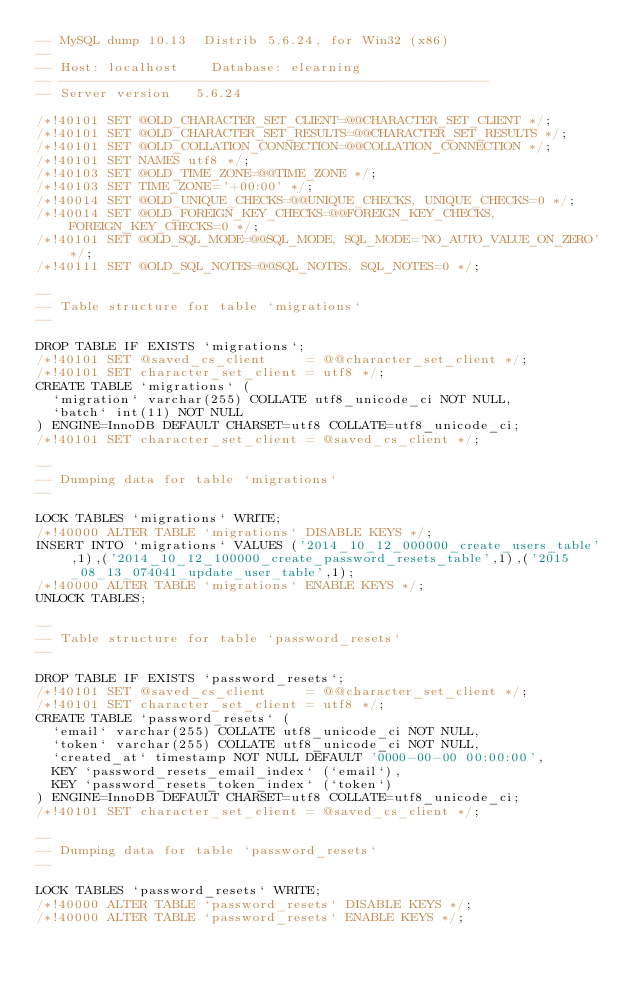Convert code to text. <code><loc_0><loc_0><loc_500><loc_500><_SQL_>-- MySQL dump 10.13  Distrib 5.6.24, for Win32 (x86)
--
-- Host: localhost    Database: elearning
-- ------------------------------------------------------
-- Server version	5.6.24

/*!40101 SET @OLD_CHARACTER_SET_CLIENT=@@CHARACTER_SET_CLIENT */;
/*!40101 SET @OLD_CHARACTER_SET_RESULTS=@@CHARACTER_SET_RESULTS */;
/*!40101 SET @OLD_COLLATION_CONNECTION=@@COLLATION_CONNECTION */;
/*!40101 SET NAMES utf8 */;
/*!40103 SET @OLD_TIME_ZONE=@@TIME_ZONE */;
/*!40103 SET TIME_ZONE='+00:00' */;
/*!40014 SET @OLD_UNIQUE_CHECKS=@@UNIQUE_CHECKS, UNIQUE_CHECKS=0 */;
/*!40014 SET @OLD_FOREIGN_KEY_CHECKS=@@FOREIGN_KEY_CHECKS, FOREIGN_KEY_CHECKS=0 */;
/*!40101 SET @OLD_SQL_MODE=@@SQL_MODE, SQL_MODE='NO_AUTO_VALUE_ON_ZERO' */;
/*!40111 SET @OLD_SQL_NOTES=@@SQL_NOTES, SQL_NOTES=0 */;

--
-- Table structure for table `migrations`
--

DROP TABLE IF EXISTS `migrations`;
/*!40101 SET @saved_cs_client     = @@character_set_client */;
/*!40101 SET character_set_client = utf8 */;
CREATE TABLE `migrations` (
  `migration` varchar(255) COLLATE utf8_unicode_ci NOT NULL,
  `batch` int(11) NOT NULL
) ENGINE=InnoDB DEFAULT CHARSET=utf8 COLLATE=utf8_unicode_ci;
/*!40101 SET character_set_client = @saved_cs_client */;

--
-- Dumping data for table `migrations`
--

LOCK TABLES `migrations` WRITE;
/*!40000 ALTER TABLE `migrations` DISABLE KEYS */;
INSERT INTO `migrations` VALUES ('2014_10_12_000000_create_users_table',1),('2014_10_12_100000_create_password_resets_table',1),('2015_08_13_074041_update_user_table',1);
/*!40000 ALTER TABLE `migrations` ENABLE KEYS */;
UNLOCK TABLES;

--
-- Table structure for table `password_resets`
--

DROP TABLE IF EXISTS `password_resets`;
/*!40101 SET @saved_cs_client     = @@character_set_client */;
/*!40101 SET character_set_client = utf8 */;
CREATE TABLE `password_resets` (
  `email` varchar(255) COLLATE utf8_unicode_ci NOT NULL,
  `token` varchar(255) COLLATE utf8_unicode_ci NOT NULL,
  `created_at` timestamp NOT NULL DEFAULT '0000-00-00 00:00:00',
  KEY `password_resets_email_index` (`email`),
  KEY `password_resets_token_index` (`token`)
) ENGINE=InnoDB DEFAULT CHARSET=utf8 COLLATE=utf8_unicode_ci;
/*!40101 SET character_set_client = @saved_cs_client */;

--
-- Dumping data for table `password_resets`
--

LOCK TABLES `password_resets` WRITE;
/*!40000 ALTER TABLE `password_resets` DISABLE KEYS */;
/*!40000 ALTER TABLE `password_resets` ENABLE KEYS */;</code> 